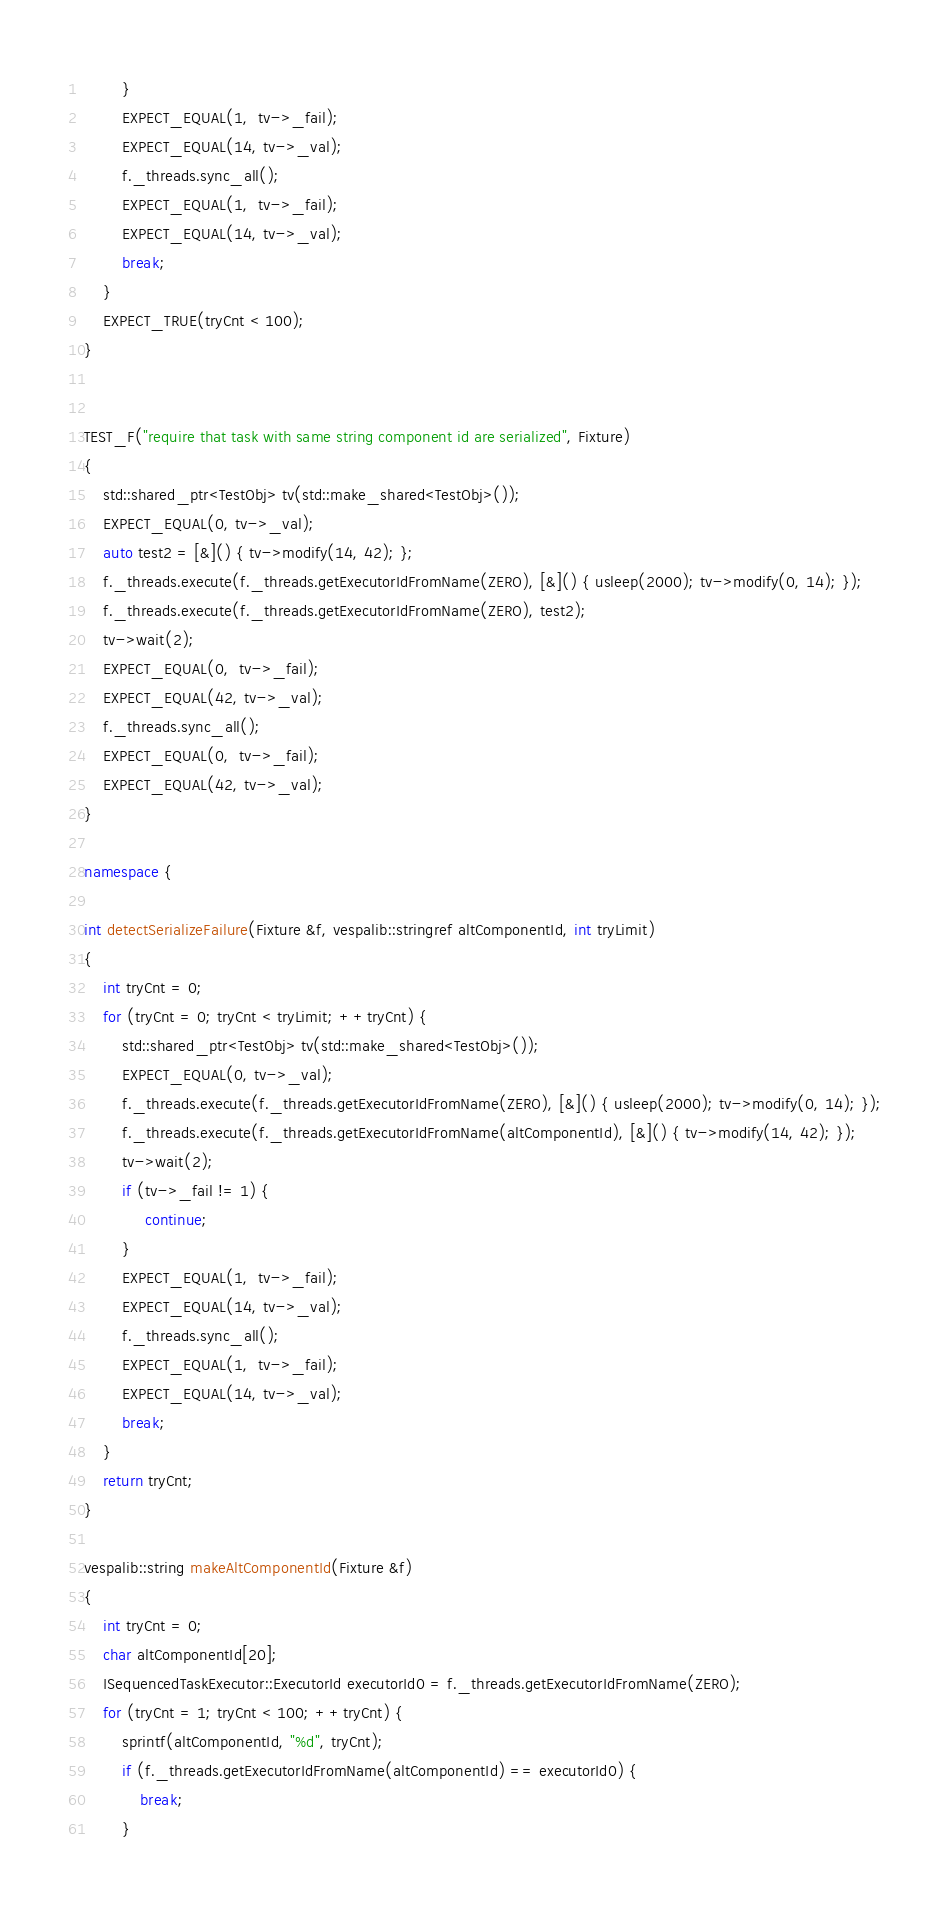<code> <loc_0><loc_0><loc_500><loc_500><_C++_>        }
        EXPECT_EQUAL(1,  tv->_fail);
        EXPECT_EQUAL(14, tv->_val);
        f._threads.sync_all();
        EXPECT_EQUAL(1,  tv->_fail);
        EXPECT_EQUAL(14, tv->_val);
        break;
    }
    EXPECT_TRUE(tryCnt < 100);
}


TEST_F("require that task with same string component id are serialized", Fixture)
{
    std::shared_ptr<TestObj> tv(std::make_shared<TestObj>());
    EXPECT_EQUAL(0, tv->_val);
    auto test2 = [&]() { tv->modify(14, 42); };
    f._threads.execute(f._threads.getExecutorIdFromName(ZERO), [&]() { usleep(2000); tv->modify(0, 14); });
    f._threads.execute(f._threads.getExecutorIdFromName(ZERO), test2);
    tv->wait(2);
    EXPECT_EQUAL(0,  tv->_fail);
    EXPECT_EQUAL(42, tv->_val);
    f._threads.sync_all();
    EXPECT_EQUAL(0,  tv->_fail);
    EXPECT_EQUAL(42, tv->_val);
}

namespace {

int detectSerializeFailure(Fixture &f, vespalib::stringref altComponentId, int tryLimit)
{
    int tryCnt = 0;
    for (tryCnt = 0; tryCnt < tryLimit; ++tryCnt) {
        std::shared_ptr<TestObj> tv(std::make_shared<TestObj>());
        EXPECT_EQUAL(0, tv->_val);
        f._threads.execute(f._threads.getExecutorIdFromName(ZERO), [&]() { usleep(2000); tv->modify(0, 14); });
        f._threads.execute(f._threads.getExecutorIdFromName(altComponentId), [&]() { tv->modify(14, 42); });
        tv->wait(2);
        if (tv->_fail != 1) {
             continue;
        }
        EXPECT_EQUAL(1,  tv->_fail);
        EXPECT_EQUAL(14, tv->_val);
        f._threads.sync_all();
        EXPECT_EQUAL(1,  tv->_fail);
        EXPECT_EQUAL(14, tv->_val);
        break;
    }
    return tryCnt;
}

vespalib::string makeAltComponentId(Fixture &f)
{
    int tryCnt = 0;
    char altComponentId[20];
    ISequencedTaskExecutor::ExecutorId executorId0 = f._threads.getExecutorIdFromName(ZERO);
    for (tryCnt = 1; tryCnt < 100; ++tryCnt) {
        sprintf(altComponentId, "%d", tryCnt);
        if (f._threads.getExecutorIdFromName(altComponentId) == executorId0) {
            break;
        }</code> 